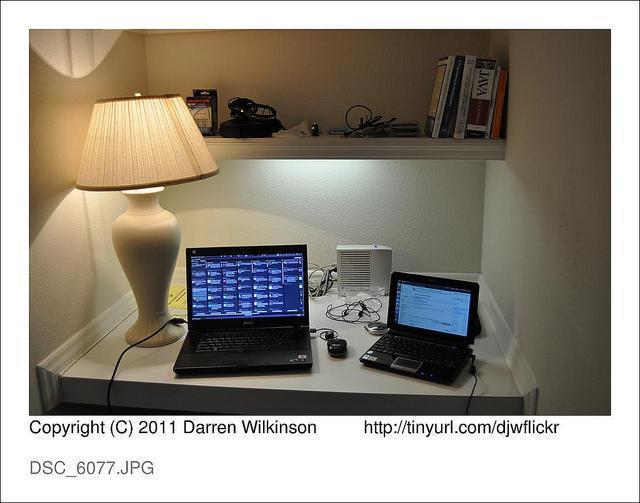How many lamps are there?
Give a very brief answer. 1. How many laptops are there?
Give a very brief answer. 2. 